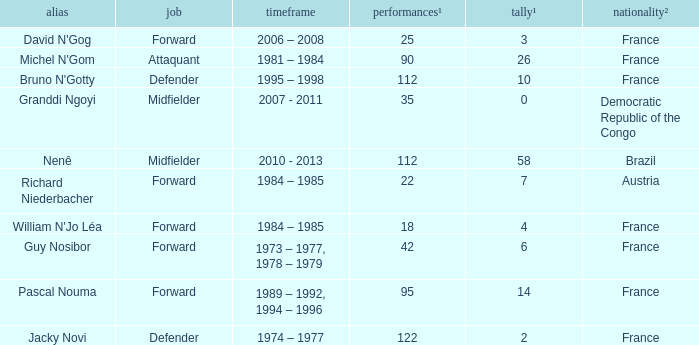How many players are from the country of Brazil? 1.0. 